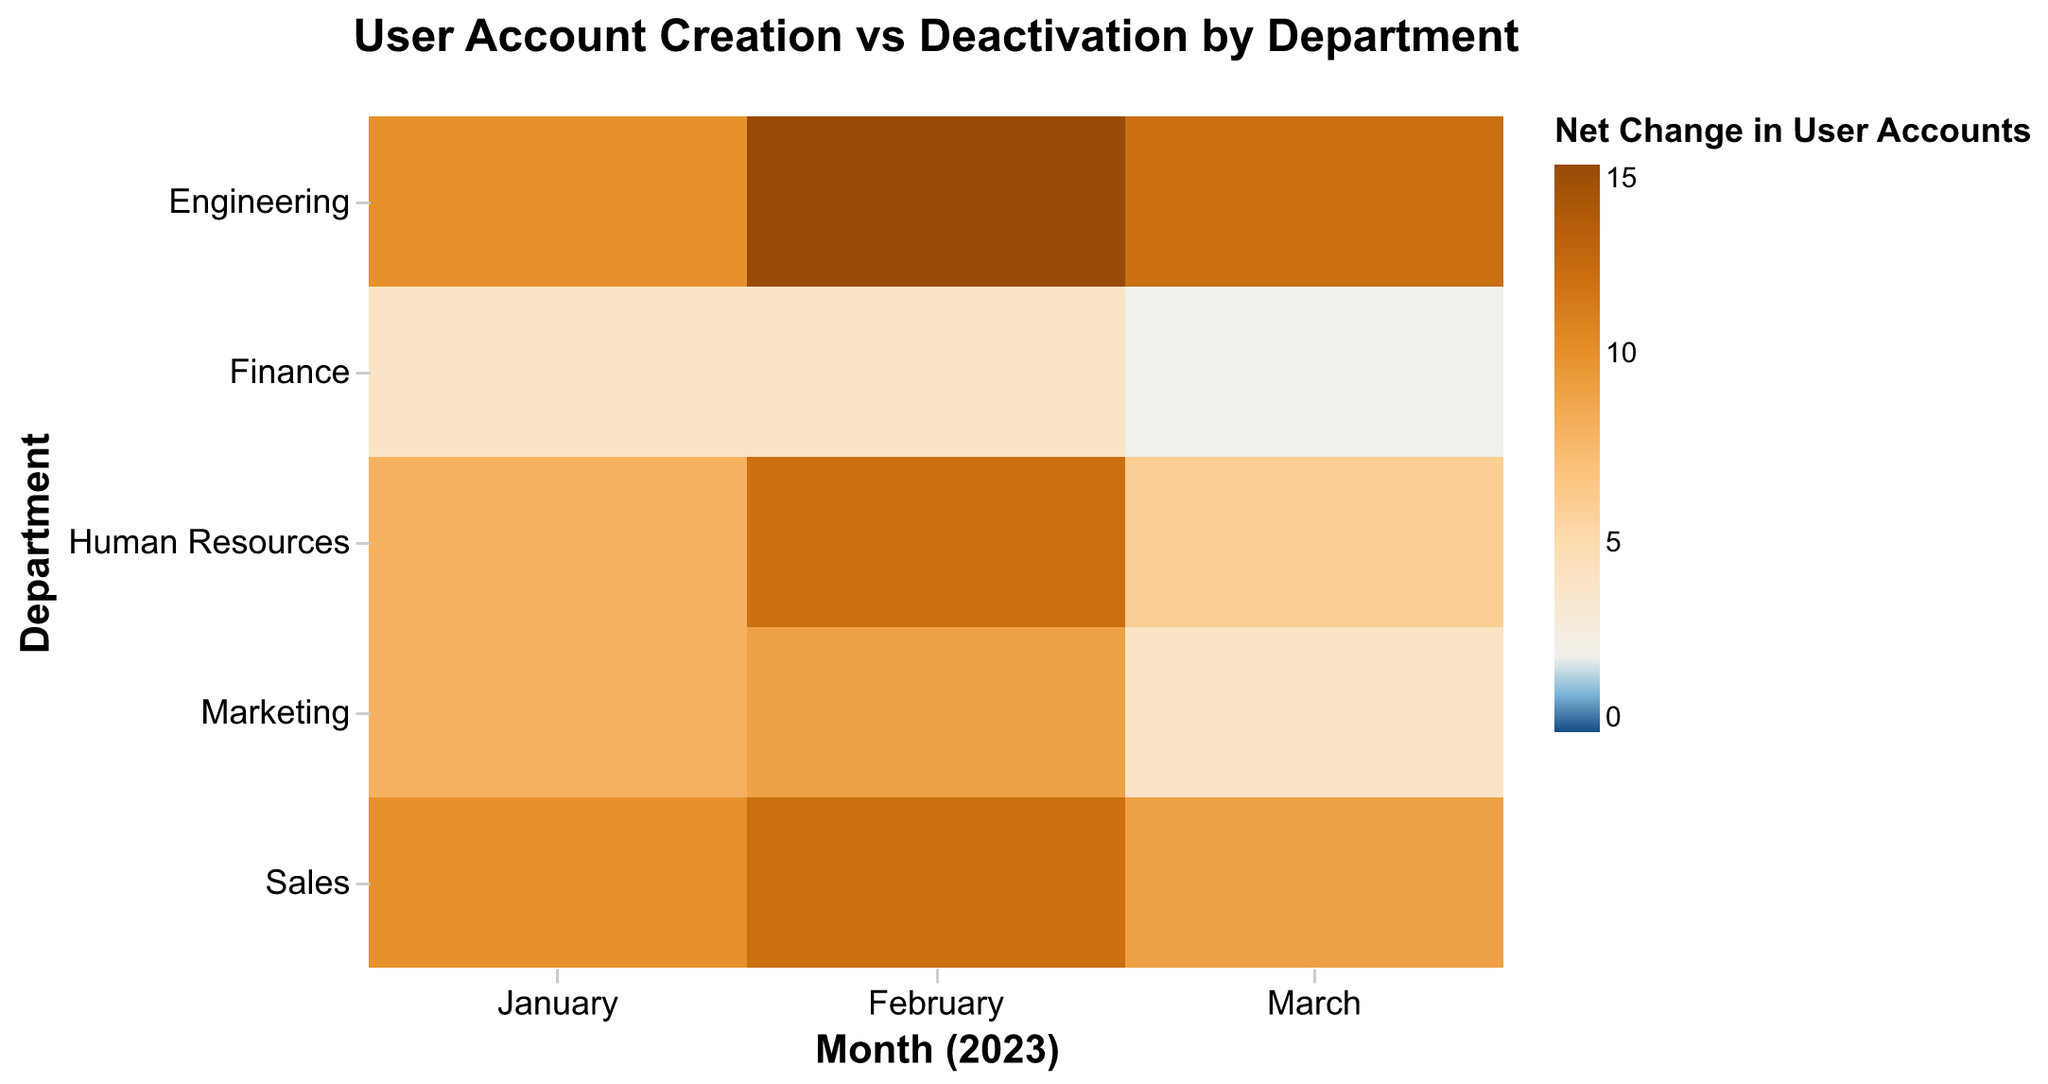What is the title of the heatmap? The title is displayed at the top of the heatmap and reads "User Account Creation vs Deactivation by Department".
Answer: User Account Creation vs Deactivation by Department Which department had the highest net change in user accounts in February 2023? The net change is color-coded, with higher positive changes being more intense blue. The Engineering department shows the most intense blue in February 2023.
Answer: Engineering Which department had the lowest account deactivation rate in January 2023? Look for the cell with "January" on the x-axis and find which cell in the "User Account Deactivation" has the lowest value. The Marketing department has a deactivation rate of 0 in January 2023.
Answer: Marketing What is the net change in user accounts for the Finance department in March 2023? Calculate the net change by subtracting account deactivations from creations for the Finance department in March. Finance had 3 creations and 1 deactivation.
Answer: 2 Which month showed the least net change across all departments? Sum the net changes for January, February, and March across all departments, and identify the month with the smallest sum. March shows the least intense colors overall, indicating the smallest net change.
Answer: March Compare the net change in user accounts between the Sales and Marketing departments in March 2023. Look for the cells corresponding to March for both Sales and Marketing. Both show subdued colors; calculate the net change: Sales (10-1=9), Marketing (7-3=4). Sales has a higher net change.
Answer: Sales What is the aggregate net change for the Human Resources department over the three-month period? Add the net changes for January, February, and March for Human Resources. (10-2)+(15-3)+(7-1) = 8+12+6 = 26
Answer: 26 Which department had the highest fluctuation in net change over the three-month period? Compare the differences in net change values for each department month-to-month. The Engineering department shows significant monthly color variation, indicating the highest fluctuation.
Answer: Engineering What trend is observed in the User Account Creation for the Engineering department from January to March? Look at the color intensity for user account creation in the Engineering department over the three months. The colors remain intense, indicating consistently higher creation rates, although slightly decreasing from February to March.
Answer: Generally high with slight decrease 